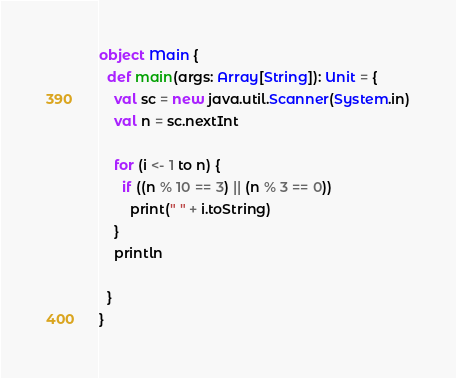Convert code to text. <code><loc_0><loc_0><loc_500><loc_500><_Scala_>object Main {
  def main(args: Array[String]): Unit = {
    val sc = new java.util.Scanner(System.in)
    val n = sc.nextInt

    for (i <- 1 to n) {
      if ((n % 10 == 3) || (n % 3 == 0))
        print(" " + i.toString)
    }
    println

  }
}</code> 